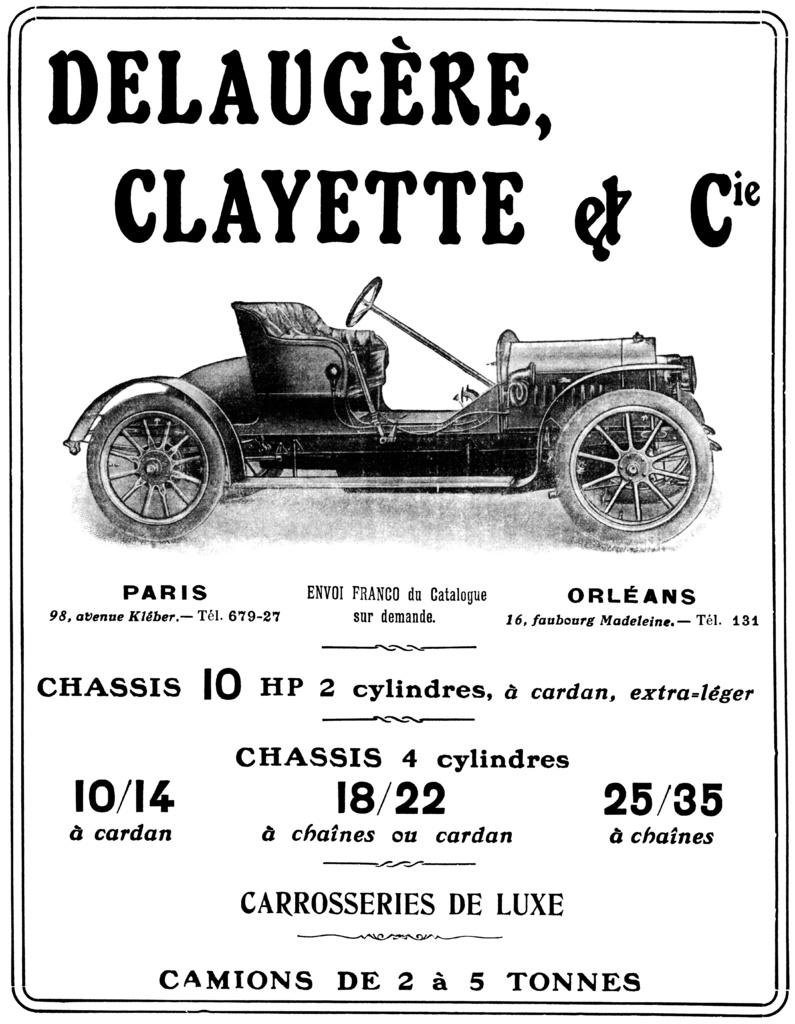What is the color scheme of the poster in the image? The poster is black and white. What type of vehicle is shown on the poster? There is a black car depicted on the poster. What color is the text on the poster? The text on the poster is written in black color. Can you tell me how many times the word "good-bye" is written on the poster? There is no mention of the word "good-bye" on the poster; it only features a black car and black text. What type of pan is shown being used with the car on the poster? There is no pan present on the poster; it only features a black car and black text. 